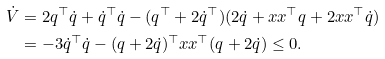<formula> <loc_0><loc_0><loc_500><loc_500>\dot { V } & = 2 q ^ { \top } \dot { q } + \dot { q } ^ { \top } \dot { q } - ( q ^ { \top } + 2 \dot { q } ^ { \top } ) ( 2 \dot { q } + x x ^ { \top } q + 2 x x ^ { \top } \dot { q } ) \\ & = - 3 \dot { q } ^ { \top } \dot { q } - ( q + 2 \dot { q } ) ^ { \top } x x ^ { \top } ( q + 2 \dot { q } ) \leq 0 .</formula> 